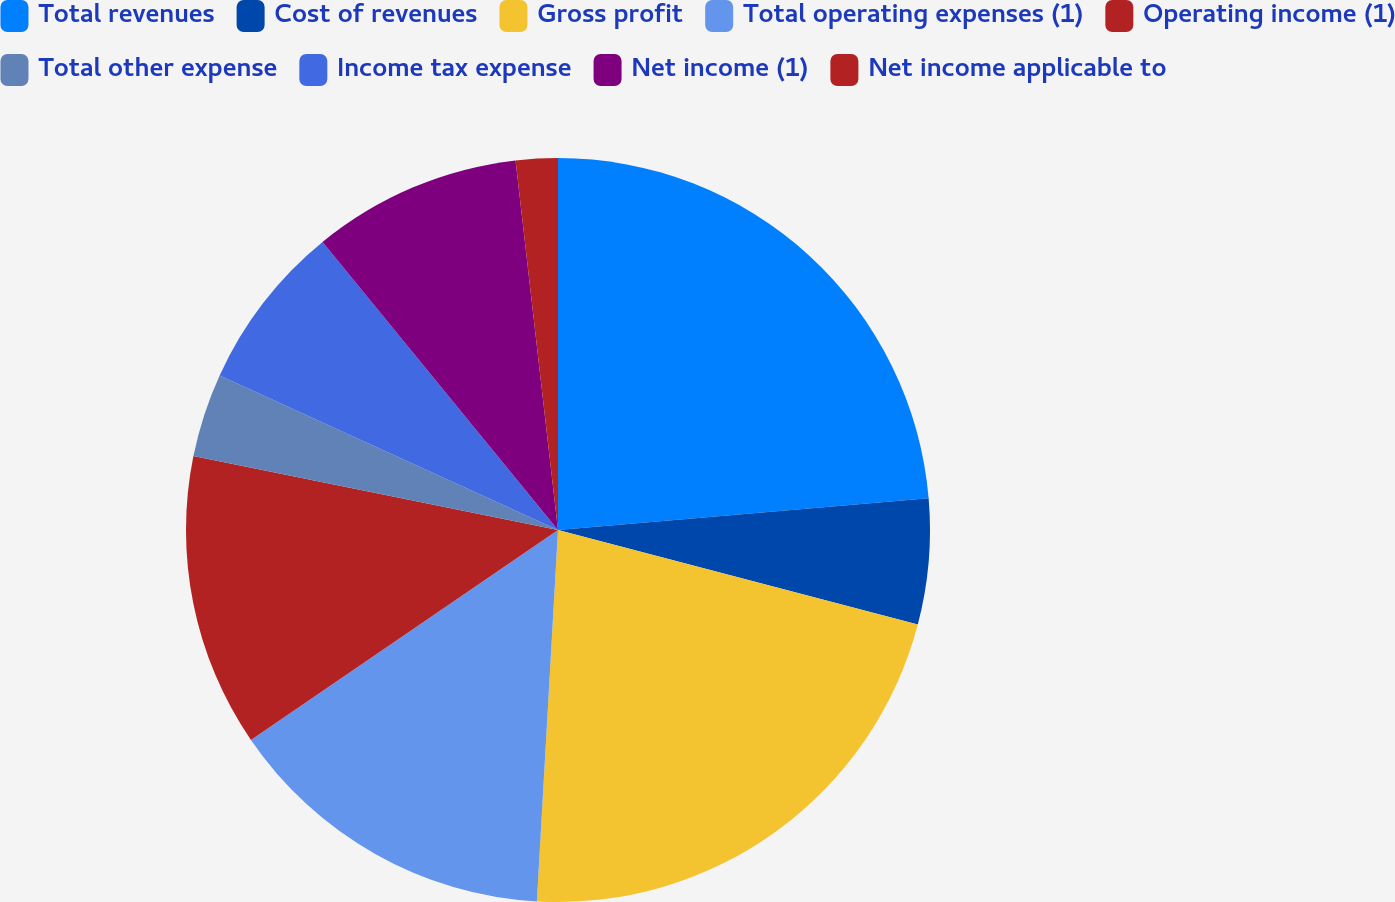<chart> <loc_0><loc_0><loc_500><loc_500><pie_chart><fcel>Total revenues<fcel>Cost of revenues<fcel>Gross profit<fcel>Total operating expenses (1)<fcel>Operating income (1)<fcel>Total other expense<fcel>Income tax expense<fcel>Net income (1)<fcel>Net income applicable to<nl><fcel>23.64%<fcel>5.45%<fcel>21.82%<fcel>14.55%<fcel>12.73%<fcel>3.64%<fcel>7.27%<fcel>9.09%<fcel>1.82%<nl></chart> 